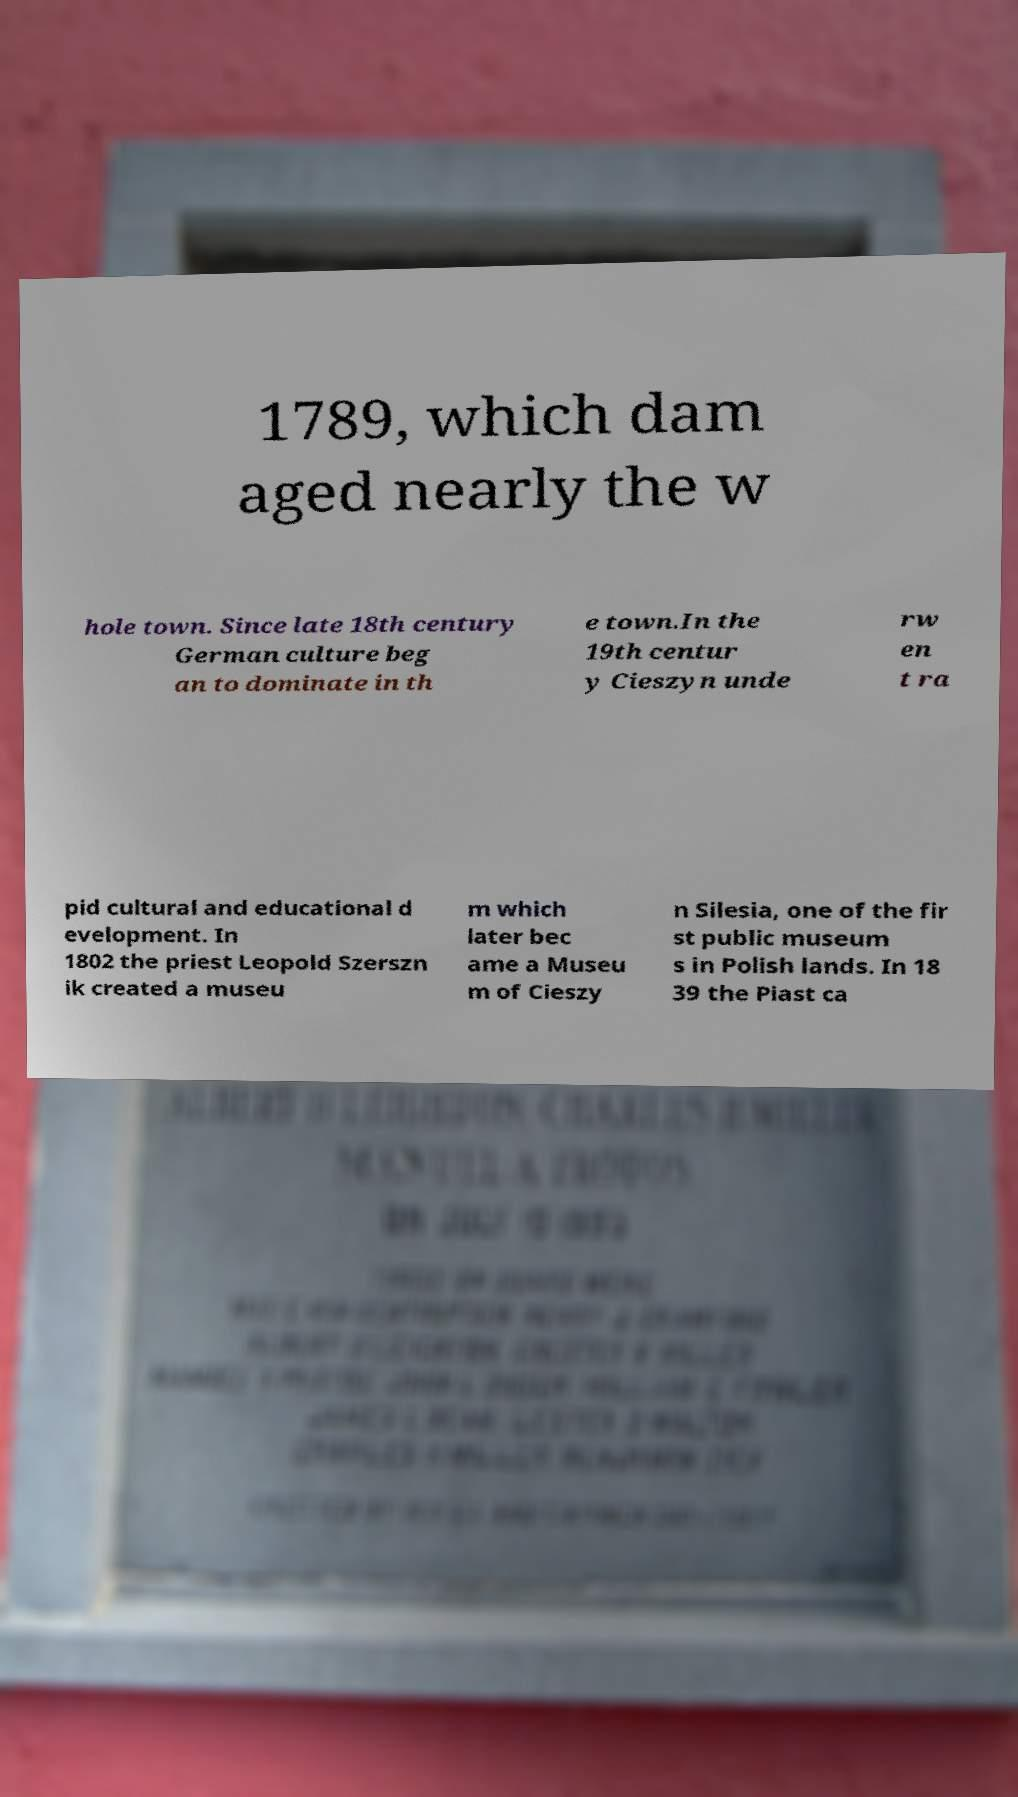Could you assist in decoding the text presented in this image and type it out clearly? 1789, which dam aged nearly the w hole town. Since late 18th century German culture beg an to dominate in th e town.In the 19th centur y Cieszyn unde rw en t ra pid cultural and educational d evelopment. In 1802 the priest Leopold Szerszn ik created a museu m which later bec ame a Museu m of Cieszy n Silesia, one of the fir st public museum s in Polish lands. In 18 39 the Piast ca 